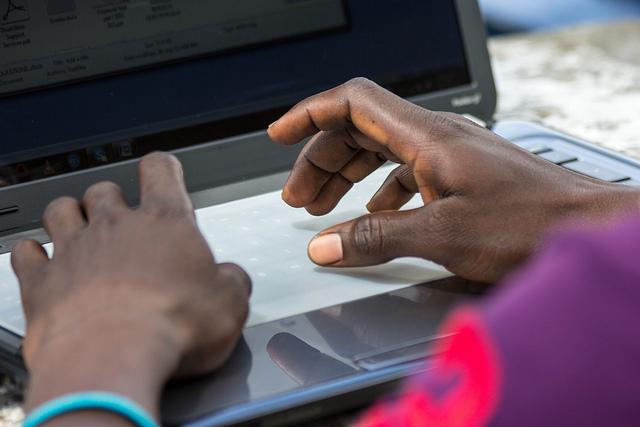Is the person typing on the keyboard?
Be succinct. Yes. What is this person's trade?
Concise answer only. Accountant. What type of device is being used?
Keep it brief. Laptop. Is that a new computer?
Short answer required. Yes. 